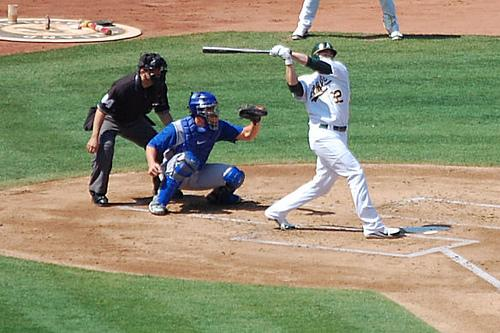What call will the umpire most likely make? strike 